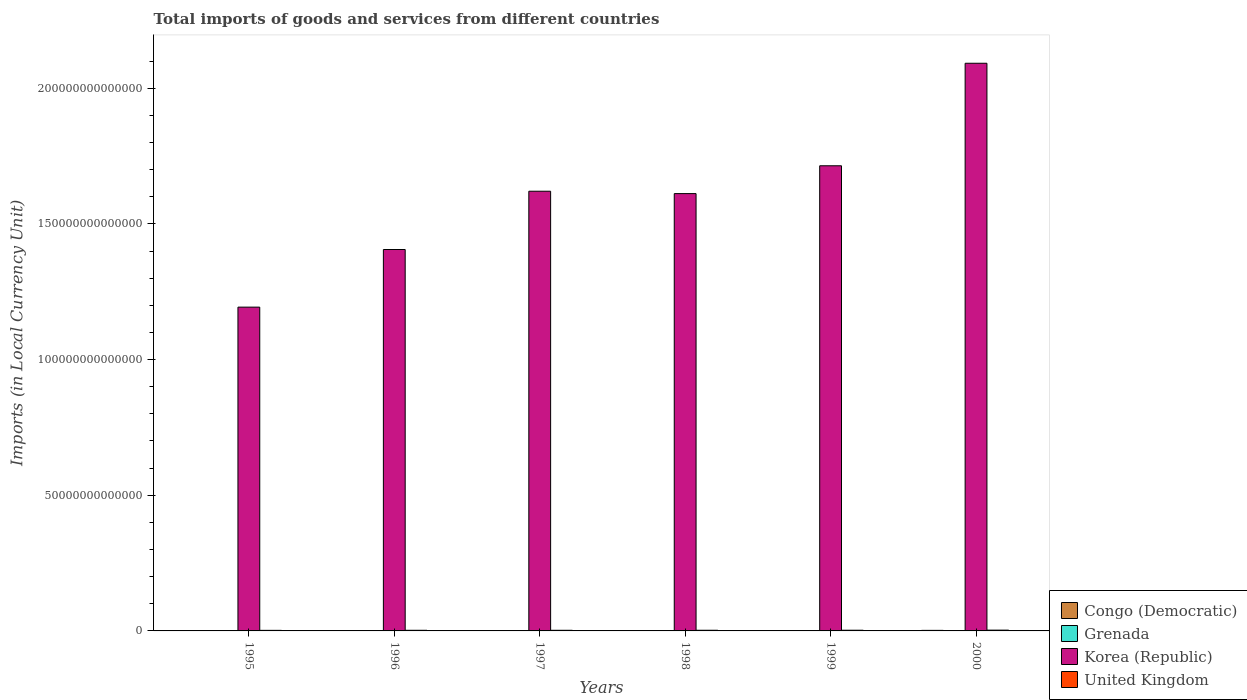How many different coloured bars are there?
Make the answer very short. 4. How many groups of bars are there?
Offer a very short reply. 6. Are the number of bars on each tick of the X-axis equal?
Ensure brevity in your answer.  Yes. How many bars are there on the 4th tick from the left?
Your response must be concise. 4. How many bars are there on the 3rd tick from the right?
Provide a short and direct response. 4. What is the label of the 3rd group of bars from the left?
Your answer should be compact. 1997. What is the Amount of goods and services imports in Grenada in 2000?
Provide a succinct answer. 8.37e+08. Across all years, what is the maximum Amount of goods and services imports in Grenada?
Your answer should be very brief. 8.37e+08. Across all years, what is the minimum Amount of goods and services imports in United Kingdom?
Your response must be concise. 2.10e+11. What is the total Amount of goods and services imports in United Kingdom in the graph?
Offer a very short reply. 1.47e+12. What is the difference between the Amount of goods and services imports in United Kingdom in 1997 and that in 1998?
Provide a short and direct response. -6.59e+09. What is the difference between the Amount of goods and services imports in United Kingdom in 1999 and the Amount of goods and services imports in Korea (Republic) in 1995?
Your response must be concise. -1.19e+14. What is the average Amount of goods and services imports in Congo (Democratic) per year?
Make the answer very short. 3.66e+1. In the year 1995, what is the difference between the Amount of goods and services imports in Congo (Democratic) and Amount of goods and services imports in Korea (Republic)?
Offer a very short reply. -1.19e+14. What is the ratio of the Amount of goods and services imports in Congo (Democratic) in 1995 to that in 1996?
Your answer should be compact. 0.11. Is the Amount of goods and services imports in United Kingdom in 1995 less than that in 1996?
Give a very brief answer. Yes. Is the difference between the Amount of goods and services imports in Congo (Democratic) in 1997 and 1998 greater than the difference between the Amount of goods and services imports in Korea (Republic) in 1997 and 1998?
Your response must be concise. No. What is the difference between the highest and the second highest Amount of goods and services imports in United Kingdom?
Give a very brief answer. 3.17e+1. What is the difference between the highest and the lowest Amount of goods and services imports in United Kingdom?
Ensure brevity in your answer.  7.99e+1. Is it the case that in every year, the sum of the Amount of goods and services imports in United Kingdom and Amount of goods and services imports in Grenada is greater than the sum of Amount of goods and services imports in Korea (Republic) and Amount of goods and services imports in Congo (Democratic)?
Provide a succinct answer. No. What does the 1st bar from the left in 1997 represents?
Provide a short and direct response. Congo (Democratic). What does the 2nd bar from the right in 1996 represents?
Offer a very short reply. Korea (Republic). Is it the case that in every year, the sum of the Amount of goods and services imports in Grenada and Amount of goods and services imports in Congo (Democratic) is greater than the Amount of goods and services imports in Korea (Republic)?
Provide a succinct answer. No. Are all the bars in the graph horizontal?
Offer a very short reply. No. What is the difference between two consecutive major ticks on the Y-axis?
Give a very brief answer. 5.00e+13. Does the graph contain any zero values?
Your response must be concise. No. How many legend labels are there?
Ensure brevity in your answer.  4. What is the title of the graph?
Keep it short and to the point. Total imports of goods and services from different countries. What is the label or title of the X-axis?
Offer a terse response. Years. What is the label or title of the Y-axis?
Give a very brief answer. Imports (in Local Currency Unit). What is the Imports (in Local Currency Unit) of Congo (Democratic) in 1995?
Ensure brevity in your answer.  9.41e+07. What is the Imports (in Local Currency Unit) of Grenada in 1995?
Your response must be concise. 4.12e+08. What is the Imports (in Local Currency Unit) in Korea (Republic) in 1995?
Ensure brevity in your answer.  1.19e+14. What is the Imports (in Local Currency Unit) in United Kingdom in 1995?
Offer a terse response. 2.10e+11. What is the Imports (in Local Currency Unit) of Congo (Democratic) in 1996?
Your answer should be very brief. 8.78e+08. What is the Imports (in Local Currency Unit) of Grenada in 1996?
Provide a short and direct response. 5.22e+08. What is the Imports (in Local Currency Unit) of Korea (Republic) in 1996?
Keep it short and to the point. 1.41e+14. What is the Imports (in Local Currency Unit) of United Kingdom in 1996?
Give a very brief answer. 2.30e+11. What is the Imports (in Local Currency Unit) of Congo (Democratic) in 1997?
Offer a very short reply. 1.20e+09. What is the Imports (in Local Currency Unit) of Grenada in 1997?
Provide a short and direct response. 5.74e+08. What is the Imports (in Local Currency Unit) in Korea (Republic) in 1997?
Ensure brevity in your answer.  1.62e+14. What is the Imports (in Local Currency Unit) of United Kingdom in 1997?
Make the answer very short. 2.35e+11. What is the Imports (in Local Currency Unit) of Congo (Democratic) in 1998?
Provide a short and direct response. 3.29e+09. What is the Imports (in Local Currency Unit) in Grenada in 1998?
Provide a short and direct response. 6.84e+08. What is the Imports (in Local Currency Unit) in Korea (Republic) in 1998?
Your answer should be compact. 1.61e+14. What is the Imports (in Local Currency Unit) in United Kingdom in 1998?
Ensure brevity in your answer.  2.42e+11. What is the Imports (in Local Currency Unit) of Congo (Democratic) in 1999?
Your response must be concise. 9.09e+09. What is the Imports (in Local Currency Unit) in Grenada in 1999?
Provide a succinct answer. 7.19e+08. What is the Imports (in Local Currency Unit) of Korea (Republic) in 1999?
Offer a very short reply. 1.71e+14. What is the Imports (in Local Currency Unit) of United Kingdom in 1999?
Your answer should be very brief. 2.58e+11. What is the Imports (in Local Currency Unit) in Congo (Democratic) in 2000?
Make the answer very short. 2.05e+11. What is the Imports (in Local Currency Unit) in Grenada in 2000?
Provide a succinct answer. 8.37e+08. What is the Imports (in Local Currency Unit) of Korea (Republic) in 2000?
Provide a short and direct response. 2.09e+14. What is the Imports (in Local Currency Unit) of United Kingdom in 2000?
Your response must be concise. 2.90e+11. Across all years, what is the maximum Imports (in Local Currency Unit) of Congo (Democratic)?
Offer a terse response. 2.05e+11. Across all years, what is the maximum Imports (in Local Currency Unit) in Grenada?
Offer a very short reply. 8.37e+08. Across all years, what is the maximum Imports (in Local Currency Unit) of Korea (Republic)?
Your answer should be very brief. 2.09e+14. Across all years, what is the maximum Imports (in Local Currency Unit) of United Kingdom?
Make the answer very short. 2.90e+11. Across all years, what is the minimum Imports (in Local Currency Unit) in Congo (Democratic)?
Provide a short and direct response. 9.41e+07. Across all years, what is the minimum Imports (in Local Currency Unit) of Grenada?
Provide a short and direct response. 4.12e+08. Across all years, what is the minimum Imports (in Local Currency Unit) of Korea (Republic)?
Offer a very short reply. 1.19e+14. Across all years, what is the minimum Imports (in Local Currency Unit) in United Kingdom?
Make the answer very short. 2.10e+11. What is the total Imports (in Local Currency Unit) in Congo (Democratic) in the graph?
Offer a very short reply. 2.20e+11. What is the total Imports (in Local Currency Unit) of Grenada in the graph?
Give a very brief answer. 3.75e+09. What is the total Imports (in Local Currency Unit) in Korea (Republic) in the graph?
Your answer should be compact. 9.64e+14. What is the total Imports (in Local Currency Unit) in United Kingdom in the graph?
Your answer should be very brief. 1.47e+12. What is the difference between the Imports (in Local Currency Unit) in Congo (Democratic) in 1995 and that in 1996?
Give a very brief answer. -7.84e+08. What is the difference between the Imports (in Local Currency Unit) in Grenada in 1995 and that in 1996?
Your answer should be compact. -1.09e+08. What is the difference between the Imports (in Local Currency Unit) in Korea (Republic) in 1995 and that in 1996?
Offer a terse response. -2.12e+13. What is the difference between the Imports (in Local Currency Unit) of United Kingdom in 1995 and that in 1996?
Offer a terse response. -2.02e+1. What is the difference between the Imports (in Local Currency Unit) in Congo (Democratic) in 1995 and that in 1997?
Your answer should be very brief. -1.11e+09. What is the difference between the Imports (in Local Currency Unit) of Grenada in 1995 and that in 1997?
Ensure brevity in your answer.  -1.62e+08. What is the difference between the Imports (in Local Currency Unit) in Korea (Republic) in 1995 and that in 1997?
Provide a short and direct response. -4.27e+13. What is the difference between the Imports (in Local Currency Unit) in United Kingdom in 1995 and that in 1997?
Make the answer very short. -2.52e+1. What is the difference between the Imports (in Local Currency Unit) in Congo (Democratic) in 1995 and that in 1998?
Offer a very short reply. -3.19e+09. What is the difference between the Imports (in Local Currency Unit) of Grenada in 1995 and that in 1998?
Provide a succinct answer. -2.71e+08. What is the difference between the Imports (in Local Currency Unit) in Korea (Republic) in 1995 and that in 1998?
Give a very brief answer. -4.18e+13. What is the difference between the Imports (in Local Currency Unit) of United Kingdom in 1995 and that in 1998?
Offer a very short reply. -3.18e+1. What is the difference between the Imports (in Local Currency Unit) in Congo (Democratic) in 1995 and that in 1999?
Make the answer very short. -9.00e+09. What is the difference between the Imports (in Local Currency Unit) of Grenada in 1995 and that in 1999?
Your response must be concise. -3.07e+08. What is the difference between the Imports (in Local Currency Unit) in Korea (Republic) in 1995 and that in 1999?
Provide a short and direct response. -5.21e+13. What is the difference between the Imports (in Local Currency Unit) in United Kingdom in 1995 and that in 1999?
Provide a succinct answer. -4.82e+1. What is the difference between the Imports (in Local Currency Unit) in Congo (Democratic) in 1995 and that in 2000?
Offer a terse response. -2.05e+11. What is the difference between the Imports (in Local Currency Unit) of Grenada in 1995 and that in 2000?
Ensure brevity in your answer.  -4.25e+08. What is the difference between the Imports (in Local Currency Unit) of Korea (Republic) in 1995 and that in 2000?
Keep it short and to the point. -8.99e+13. What is the difference between the Imports (in Local Currency Unit) of United Kingdom in 1995 and that in 2000?
Make the answer very short. -7.99e+1. What is the difference between the Imports (in Local Currency Unit) of Congo (Democratic) in 1996 and that in 1997?
Make the answer very short. -3.22e+08. What is the difference between the Imports (in Local Currency Unit) of Grenada in 1996 and that in 1997?
Provide a short and direct response. -5.24e+07. What is the difference between the Imports (in Local Currency Unit) of Korea (Republic) in 1996 and that in 1997?
Provide a succinct answer. -2.15e+13. What is the difference between the Imports (in Local Currency Unit) of United Kingdom in 1996 and that in 1997?
Provide a succinct answer. -4.98e+09. What is the difference between the Imports (in Local Currency Unit) of Congo (Democratic) in 1996 and that in 1998?
Your response must be concise. -2.41e+09. What is the difference between the Imports (in Local Currency Unit) of Grenada in 1996 and that in 1998?
Offer a very short reply. -1.62e+08. What is the difference between the Imports (in Local Currency Unit) in Korea (Republic) in 1996 and that in 1998?
Provide a succinct answer. -2.06e+13. What is the difference between the Imports (in Local Currency Unit) of United Kingdom in 1996 and that in 1998?
Your response must be concise. -1.16e+1. What is the difference between the Imports (in Local Currency Unit) of Congo (Democratic) in 1996 and that in 1999?
Your answer should be very brief. -8.21e+09. What is the difference between the Imports (in Local Currency Unit) in Grenada in 1996 and that in 1999?
Offer a terse response. -1.97e+08. What is the difference between the Imports (in Local Currency Unit) in Korea (Republic) in 1996 and that in 1999?
Your answer should be compact. -3.09e+13. What is the difference between the Imports (in Local Currency Unit) in United Kingdom in 1996 and that in 1999?
Offer a very short reply. -2.80e+1. What is the difference between the Imports (in Local Currency Unit) of Congo (Democratic) in 1996 and that in 2000?
Ensure brevity in your answer.  -2.04e+11. What is the difference between the Imports (in Local Currency Unit) of Grenada in 1996 and that in 2000?
Offer a terse response. -3.16e+08. What is the difference between the Imports (in Local Currency Unit) in Korea (Republic) in 1996 and that in 2000?
Offer a very short reply. -6.86e+13. What is the difference between the Imports (in Local Currency Unit) of United Kingdom in 1996 and that in 2000?
Provide a short and direct response. -5.97e+1. What is the difference between the Imports (in Local Currency Unit) of Congo (Democratic) in 1997 and that in 1998?
Provide a succinct answer. -2.09e+09. What is the difference between the Imports (in Local Currency Unit) of Grenada in 1997 and that in 1998?
Give a very brief answer. -1.10e+08. What is the difference between the Imports (in Local Currency Unit) of Korea (Republic) in 1997 and that in 1998?
Your answer should be very brief. 8.76e+11. What is the difference between the Imports (in Local Currency Unit) in United Kingdom in 1997 and that in 1998?
Provide a short and direct response. -6.59e+09. What is the difference between the Imports (in Local Currency Unit) of Congo (Democratic) in 1997 and that in 1999?
Your answer should be compact. -7.89e+09. What is the difference between the Imports (in Local Currency Unit) in Grenada in 1997 and that in 1999?
Keep it short and to the point. -1.45e+08. What is the difference between the Imports (in Local Currency Unit) of Korea (Republic) in 1997 and that in 1999?
Your answer should be compact. -9.38e+12. What is the difference between the Imports (in Local Currency Unit) in United Kingdom in 1997 and that in 1999?
Your response must be concise. -2.30e+1. What is the difference between the Imports (in Local Currency Unit) of Congo (Democratic) in 1997 and that in 2000?
Make the answer very short. -2.04e+11. What is the difference between the Imports (in Local Currency Unit) of Grenada in 1997 and that in 2000?
Your answer should be very brief. -2.63e+08. What is the difference between the Imports (in Local Currency Unit) in Korea (Republic) in 1997 and that in 2000?
Your answer should be very brief. -4.72e+13. What is the difference between the Imports (in Local Currency Unit) in United Kingdom in 1997 and that in 2000?
Provide a succinct answer. -5.47e+1. What is the difference between the Imports (in Local Currency Unit) in Congo (Democratic) in 1998 and that in 1999?
Your answer should be very brief. -5.81e+09. What is the difference between the Imports (in Local Currency Unit) in Grenada in 1998 and that in 1999?
Offer a terse response. -3.54e+07. What is the difference between the Imports (in Local Currency Unit) of Korea (Republic) in 1998 and that in 1999?
Give a very brief answer. -1.03e+13. What is the difference between the Imports (in Local Currency Unit) in United Kingdom in 1998 and that in 1999?
Keep it short and to the point. -1.64e+1. What is the difference between the Imports (in Local Currency Unit) of Congo (Democratic) in 1998 and that in 2000?
Provide a succinct answer. -2.02e+11. What is the difference between the Imports (in Local Currency Unit) in Grenada in 1998 and that in 2000?
Provide a succinct answer. -1.54e+08. What is the difference between the Imports (in Local Currency Unit) of Korea (Republic) in 1998 and that in 2000?
Make the answer very short. -4.80e+13. What is the difference between the Imports (in Local Currency Unit) of United Kingdom in 1998 and that in 2000?
Your answer should be compact. -4.81e+1. What is the difference between the Imports (in Local Currency Unit) of Congo (Democratic) in 1999 and that in 2000?
Provide a succinct answer. -1.96e+11. What is the difference between the Imports (in Local Currency Unit) of Grenada in 1999 and that in 2000?
Give a very brief answer. -1.18e+08. What is the difference between the Imports (in Local Currency Unit) in Korea (Republic) in 1999 and that in 2000?
Give a very brief answer. -3.78e+13. What is the difference between the Imports (in Local Currency Unit) of United Kingdom in 1999 and that in 2000?
Offer a very short reply. -3.17e+1. What is the difference between the Imports (in Local Currency Unit) of Congo (Democratic) in 1995 and the Imports (in Local Currency Unit) of Grenada in 1996?
Give a very brief answer. -4.28e+08. What is the difference between the Imports (in Local Currency Unit) of Congo (Democratic) in 1995 and the Imports (in Local Currency Unit) of Korea (Republic) in 1996?
Provide a succinct answer. -1.41e+14. What is the difference between the Imports (in Local Currency Unit) of Congo (Democratic) in 1995 and the Imports (in Local Currency Unit) of United Kingdom in 1996?
Provide a short and direct response. -2.30e+11. What is the difference between the Imports (in Local Currency Unit) in Grenada in 1995 and the Imports (in Local Currency Unit) in Korea (Republic) in 1996?
Your response must be concise. -1.41e+14. What is the difference between the Imports (in Local Currency Unit) of Grenada in 1995 and the Imports (in Local Currency Unit) of United Kingdom in 1996?
Make the answer very short. -2.30e+11. What is the difference between the Imports (in Local Currency Unit) of Korea (Republic) in 1995 and the Imports (in Local Currency Unit) of United Kingdom in 1996?
Your answer should be compact. 1.19e+14. What is the difference between the Imports (in Local Currency Unit) in Congo (Democratic) in 1995 and the Imports (in Local Currency Unit) in Grenada in 1997?
Your answer should be compact. -4.80e+08. What is the difference between the Imports (in Local Currency Unit) of Congo (Democratic) in 1995 and the Imports (in Local Currency Unit) of Korea (Republic) in 1997?
Offer a very short reply. -1.62e+14. What is the difference between the Imports (in Local Currency Unit) of Congo (Democratic) in 1995 and the Imports (in Local Currency Unit) of United Kingdom in 1997?
Provide a short and direct response. -2.35e+11. What is the difference between the Imports (in Local Currency Unit) in Grenada in 1995 and the Imports (in Local Currency Unit) in Korea (Republic) in 1997?
Give a very brief answer. -1.62e+14. What is the difference between the Imports (in Local Currency Unit) of Grenada in 1995 and the Imports (in Local Currency Unit) of United Kingdom in 1997?
Your answer should be very brief. -2.35e+11. What is the difference between the Imports (in Local Currency Unit) in Korea (Republic) in 1995 and the Imports (in Local Currency Unit) in United Kingdom in 1997?
Your response must be concise. 1.19e+14. What is the difference between the Imports (in Local Currency Unit) in Congo (Democratic) in 1995 and the Imports (in Local Currency Unit) in Grenada in 1998?
Give a very brief answer. -5.90e+08. What is the difference between the Imports (in Local Currency Unit) of Congo (Democratic) in 1995 and the Imports (in Local Currency Unit) of Korea (Republic) in 1998?
Offer a very short reply. -1.61e+14. What is the difference between the Imports (in Local Currency Unit) in Congo (Democratic) in 1995 and the Imports (in Local Currency Unit) in United Kingdom in 1998?
Make the answer very short. -2.42e+11. What is the difference between the Imports (in Local Currency Unit) of Grenada in 1995 and the Imports (in Local Currency Unit) of Korea (Republic) in 1998?
Ensure brevity in your answer.  -1.61e+14. What is the difference between the Imports (in Local Currency Unit) in Grenada in 1995 and the Imports (in Local Currency Unit) in United Kingdom in 1998?
Ensure brevity in your answer.  -2.41e+11. What is the difference between the Imports (in Local Currency Unit) in Korea (Republic) in 1995 and the Imports (in Local Currency Unit) in United Kingdom in 1998?
Make the answer very short. 1.19e+14. What is the difference between the Imports (in Local Currency Unit) in Congo (Democratic) in 1995 and the Imports (in Local Currency Unit) in Grenada in 1999?
Your answer should be compact. -6.25e+08. What is the difference between the Imports (in Local Currency Unit) of Congo (Democratic) in 1995 and the Imports (in Local Currency Unit) of Korea (Republic) in 1999?
Provide a succinct answer. -1.71e+14. What is the difference between the Imports (in Local Currency Unit) in Congo (Democratic) in 1995 and the Imports (in Local Currency Unit) in United Kingdom in 1999?
Keep it short and to the point. -2.58e+11. What is the difference between the Imports (in Local Currency Unit) in Grenada in 1995 and the Imports (in Local Currency Unit) in Korea (Republic) in 1999?
Offer a terse response. -1.71e+14. What is the difference between the Imports (in Local Currency Unit) in Grenada in 1995 and the Imports (in Local Currency Unit) in United Kingdom in 1999?
Provide a short and direct response. -2.58e+11. What is the difference between the Imports (in Local Currency Unit) in Korea (Republic) in 1995 and the Imports (in Local Currency Unit) in United Kingdom in 1999?
Ensure brevity in your answer.  1.19e+14. What is the difference between the Imports (in Local Currency Unit) of Congo (Democratic) in 1995 and the Imports (in Local Currency Unit) of Grenada in 2000?
Keep it short and to the point. -7.43e+08. What is the difference between the Imports (in Local Currency Unit) of Congo (Democratic) in 1995 and the Imports (in Local Currency Unit) of Korea (Republic) in 2000?
Your response must be concise. -2.09e+14. What is the difference between the Imports (in Local Currency Unit) of Congo (Democratic) in 1995 and the Imports (in Local Currency Unit) of United Kingdom in 2000?
Give a very brief answer. -2.90e+11. What is the difference between the Imports (in Local Currency Unit) of Grenada in 1995 and the Imports (in Local Currency Unit) of Korea (Republic) in 2000?
Offer a very short reply. -2.09e+14. What is the difference between the Imports (in Local Currency Unit) in Grenada in 1995 and the Imports (in Local Currency Unit) in United Kingdom in 2000?
Your response must be concise. -2.90e+11. What is the difference between the Imports (in Local Currency Unit) in Korea (Republic) in 1995 and the Imports (in Local Currency Unit) in United Kingdom in 2000?
Ensure brevity in your answer.  1.19e+14. What is the difference between the Imports (in Local Currency Unit) in Congo (Democratic) in 1996 and the Imports (in Local Currency Unit) in Grenada in 1997?
Offer a very short reply. 3.04e+08. What is the difference between the Imports (in Local Currency Unit) of Congo (Democratic) in 1996 and the Imports (in Local Currency Unit) of Korea (Republic) in 1997?
Ensure brevity in your answer.  -1.62e+14. What is the difference between the Imports (in Local Currency Unit) of Congo (Democratic) in 1996 and the Imports (in Local Currency Unit) of United Kingdom in 1997?
Give a very brief answer. -2.34e+11. What is the difference between the Imports (in Local Currency Unit) in Grenada in 1996 and the Imports (in Local Currency Unit) in Korea (Republic) in 1997?
Provide a succinct answer. -1.62e+14. What is the difference between the Imports (in Local Currency Unit) of Grenada in 1996 and the Imports (in Local Currency Unit) of United Kingdom in 1997?
Provide a short and direct response. -2.35e+11. What is the difference between the Imports (in Local Currency Unit) of Korea (Republic) in 1996 and the Imports (in Local Currency Unit) of United Kingdom in 1997?
Offer a very short reply. 1.40e+14. What is the difference between the Imports (in Local Currency Unit) in Congo (Democratic) in 1996 and the Imports (in Local Currency Unit) in Grenada in 1998?
Keep it short and to the point. 1.94e+08. What is the difference between the Imports (in Local Currency Unit) in Congo (Democratic) in 1996 and the Imports (in Local Currency Unit) in Korea (Republic) in 1998?
Your response must be concise. -1.61e+14. What is the difference between the Imports (in Local Currency Unit) of Congo (Democratic) in 1996 and the Imports (in Local Currency Unit) of United Kingdom in 1998?
Your answer should be compact. -2.41e+11. What is the difference between the Imports (in Local Currency Unit) of Grenada in 1996 and the Imports (in Local Currency Unit) of Korea (Republic) in 1998?
Offer a terse response. -1.61e+14. What is the difference between the Imports (in Local Currency Unit) of Grenada in 1996 and the Imports (in Local Currency Unit) of United Kingdom in 1998?
Your answer should be very brief. -2.41e+11. What is the difference between the Imports (in Local Currency Unit) in Korea (Republic) in 1996 and the Imports (in Local Currency Unit) in United Kingdom in 1998?
Provide a short and direct response. 1.40e+14. What is the difference between the Imports (in Local Currency Unit) in Congo (Democratic) in 1996 and the Imports (in Local Currency Unit) in Grenada in 1999?
Give a very brief answer. 1.59e+08. What is the difference between the Imports (in Local Currency Unit) in Congo (Democratic) in 1996 and the Imports (in Local Currency Unit) in Korea (Republic) in 1999?
Your answer should be compact. -1.71e+14. What is the difference between the Imports (in Local Currency Unit) of Congo (Democratic) in 1996 and the Imports (in Local Currency Unit) of United Kingdom in 1999?
Your answer should be very brief. -2.57e+11. What is the difference between the Imports (in Local Currency Unit) in Grenada in 1996 and the Imports (in Local Currency Unit) in Korea (Republic) in 1999?
Your answer should be very brief. -1.71e+14. What is the difference between the Imports (in Local Currency Unit) of Grenada in 1996 and the Imports (in Local Currency Unit) of United Kingdom in 1999?
Offer a very short reply. -2.58e+11. What is the difference between the Imports (in Local Currency Unit) of Korea (Republic) in 1996 and the Imports (in Local Currency Unit) of United Kingdom in 1999?
Provide a short and direct response. 1.40e+14. What is the difference between the Imports (in Local Currency Unit) in Congo (Democratic) in 1996 and the Imports (in Local Currency Unit) in Grenada in 2000?
Give a very brief answer. 4.06e+07. What is the difference between the Imports (in Local Currency Unit) of Congo (Democratic) in 1996 and the Imports (in Local Currency Unit) of Korea (Republic) in 2000?
Give a very brief answer. -2.09e+14. What is the difference between the Imports (in Local Currency Unit) of Congo (Democratic) in 1996 and the Imports (in Local Currency Unit) of United Kingdom in 2000?
Offer a terse response. -2.89e+11. What is the difference between the Imports (in Local Currency Unit) in Grenada in 1996 and the Imports (in Local Currency Unit) in Korea (Republic) in 2000?
Offer a very short reply. -2.09e+14. What is the difference between the Imports (in Local Currency Unit) of Grenada in 1996 and the Imports (in Local Currency Unit) of United Kingdom in 2000?
Give a very brief answer. -2.89e+11. What is the difference between the Imports (in Local Currency Unit) of Korea (Republic) in 1996 and the Imports (in Local Currency Unit) of United Kingdom in 2000?
Provide a short and direct response. 1.40e+14. What is the difference between the Imports (in Local Currency Unit) of Congo (Democratic) in 1997 and the Imports (in Local Currency Unit) of Grenada in 1998?
Keep it short and to the point. 5.16e+08. What is the difference between the Imports (in Local Currency Unit) of Congo (Democratic) in 1997 and the Imports (in Local Currency Unit) of Korea (Republic) in 1998?
Provide a short and direct response. -1.61e+14. What is the difference between the Imports (in Local Currency Unit) in Congo (Democratic) in 1997 and the Imports (in Local Currency Unit) in United Kingdom in 1998?
Offer a terse response. -2.41e+11. What is the difference between the Imports (in Local Currency Unit) of Grenada in 1997 and the Imports (in Local Currency Unit) of Korea (Republic) in 1998?
Offer a terse response. -1.61e+14. What is the difference between the Imports (in Local Currency Unit) in Grenada in 1997 and the Imports (in Local Currency Unit) in United Kingdom in 1998?
Provide a succinct answer. -2.41e+11. What is the difference between the Imports (in Local Currency Unit) in Korea (Republic) in 1997 and the Imports (in Local Currency Unit) in United Kingdom in 1998?
Ensure brevity in your answer.  1.62e+14. What is the difference between the Imports (in Local Currency Unit) in Congo (Democratic) in 1997 and the Imports (in Local Currency Unit) in Grenada in 1999?
Offer a terse response. 4.81e+08. What is the difference between the Imports (in Local Currency Unit) in Congo (Democratic) in 1997 and the Imports (in Local Currency Unit) in Korea (Republic) in 1999?
Offer a very short reply. -1.71e+14. What is the difference between the Imports (in Local Currency Unit) of Congo (Democratic) in 1997 and the Imports (in Local Currency Unit) of United Kingdom in 1999?
Your answer should be very brief. -2.57e+11. What is the difference between the Imports (in Local Currency Unit) in Grenada in 1997 and the Imports (in Local Currency Unit) in Korea (Republic) in 1999?
Provide a succinct answer. -1.71e+14. What is the difference between the Imports (in Local Currency Unit) of Grenada in 1997 and the Imports (in Local Currency Unit) of United Kingdom in 1999?
Your response must be concise. -2.58e+11. What is the difference between the Imports (in Local Currency Unit) of Korea (Republic) in 1997 and the Imports (in Local Currency Unit) of United Kingdom in 1999?
Your response must be concise. 1.62e+14. What is the difference between the Imports (in Local Currency Unit) in Congo (Democratic) in 1997 and the Imports (in Local Currency Unit) in Grenada in 2000?
Your answer should be very brief. 3.63e+08. What is the difference between the Imports (in Local Currency Unit) of Congo (Democratic) in 1997 and the Imports (in Local Currency Unit) of Korea (Republic) in 2000?
Provide a succinct answer. -2.09e+14. What is the difference between the Imports (in Local Currency Unit) in Congo (Democratic) in 1997 and the Imports (in Local Currency Unit) in United Kingdom in 2000?
Your response must be concise. -2.89e+11. What is the difference between the Imports (in Local Currency Unit) of Grenada in 1997 and the Imports (in Local Currency Unit) of Korea (Republic) in 2000?
Make the answer very short. -2.09e+14. What is the difference between the Imports (in Local Currency Unit) in Grenada in 1997 and the Imports (in Local Currency Unit) in United Kingdom in 2000?
Keep it short and to the point. -2.89e+11. What is the difference between the Imports (in Local Currency Unit) of Korea (Republic) in 1997 and the Imports (in Local Currency Unit) of United Kingdom in 2000?
Your answer should be compact. 1.62e+14. What is the difference between the Imports (in Local Currency Unit) in Congo (Democratic) in 1998 and the Imports (in Local Currency Unit) in Grenada in 1999?
Your response must be concise. 2.57e+09. What is the difference between the Imports (in Local Currency Unit) of Congo (Democratic) in 1998 and the Imports (in Local Currency Unit) of Korea (Republic) in 1999?
Give a very brief answer. -1.71e+14. What is the difference between the Imports (in Local Currency Unit) of Congo (Democratic) in 1998 and the Imports (in Local Currency Unit) of United Kingdom in 1999?
Your answer should be compact. -2.55e+11. What is the difference between the Imports (in Local Currency Unit) in Grenada in 1998 and the Imports (in Local Currency Unit) in Korea (Republic) in 1999?
Your answer should be compact. -1.71e+14. What is the difference between the Imports (in Local Currency Unit) of Grenada in 1998 and the Imports (in Local Currency Unit) of United Kingdom in 1999?
Offer a terse response. -2.58e+11. What is the difference between the Imports (in Local Currency Unit) of Korea (Republic) in 1998 and the Imports (in Local Currency Unit) of United Kingdom in 1999?
Give a very brief answer. 1.61e+14. What is the difference between the Imports (in Local Currency Unit) of Congo (Democratic) in 1998 and the Imports (in Local Currency Unit) of Grenada in 2000?
Your answer should be compact. 2.45e+09. What is the difference between the Imports (in Local Currency Unit) of Congo (Democratic) in 1998 and the Imports (in Local Currency Unit) of Korea (Republic) in 2000?
Your answer should be compact. -2.09e+14. What is the difference between the Imports (in Local Currency Unit) in Congo (Democratic) in 1998 and the Imports (in Local Currency Unit) in United Kingdom in 2000?
Your response must be concise. -2.87e+11. What is the difference between the Imports (in Local Currency Unit) of Grenada in 1998 and the Imports (in Local Currency Unit) of Korea (Republic) in 2000?
Your answer should be compact. -2.09e+14. What is the difference between the Imports (in Local Currency Unit) of Grenada in 1998 and the Imports (in Local Currency Unit) of United Kingdom in 2000?
Give a very brief answer. -2.89e+11. What is the difference between the Imports (in Local Currency Unit) of Korea (Republic) in 1998 and the Imports (in Local Currency Unit) of United Kingdom in 2000?
Keep it short and to the point. 1.61e+14. What is the difference between the Imports (in Local Currency Unit) in Congo (Democratic) in 1999 and the Imports (in Local Currency Unit) in Grenada in 2000?
Provide a short and direct response. 8.25e+09. What is the difference between the Imports (in Local Currency Unit) of Congo (Democratic) in 1999 and the Imports (in Local Currency Unit) of Korea (Republic) in 2000?
Provide a succinct answer. -2.09e+14. What is the difference between the Imports (in Local Currency Unit) in Congo (Democratic) in 1999 and the Imports (in Local Currency Unit) in United Kingdom in 2000?
Provide a short and direct response. -2.81e+11. What is the difference between the Imports (in Local Currency Unit) of Grenada in 1999 and the Imports (in Local Currency Unit) of Korea (Republic) in 2000?
Provide a short and direct response. -2.09e+14. What is the difference between the Imports (in Local Currency Unit) in Grenada in 1999 and the Imports (in Local Currency Unit) in United Kingdom in 2000?
Provide a short and direct response. -2.89e+11. What is the difference between the Imports (in Local Currency Unit) in Korea (Republic) in 1999 and the Imports (in Local Currency Unit) in United Kingdom in 2000?
Your answer should be very brief. 1.71e+14. What is the average Imports (in Local Currency Unit) in Congo (Democratic) per year?
Offer a terse response. 3.66e+1. What is the average Imports (in Local Currency Unit) of Grenada per year?
Provide a short and direct response. 6.25e+08. What is the average Imports (in Local Currency Unit) in Korea (Republic) per year?
Ensure brevity in your answer.  1.61e+14. What is the average Imports (in Local Currency Unit) in United Kingdom per year?
Your answer should be very brief. 2.44e+11. In the year 1995, what is the difference between the Imports (in Local Currency Unit) of Congo (Democratic) and Imports (in Local Currency Unit) of Grenada?
Ensure brevity in your answer.  -3.18e+08. In the year 1995, what is the difference between the Imports (in Local Currency Unit) in Congo (Democratic) and Imports (in Local Currency Unit) in Korea (Republic)?
Offer a very short reply. -1.19e+14. In the year 1995, what is the difference between the Imports (in Local Currency Unit) of Congo (Democratic) and Imports (in Local Currency Unit) of United Kingdom?
Offer a very short reply. -2.10e+11. In the year 1995, what is the difference between the Imports (in Local Currency Unit) in Grenada and Imports (in Local Currency Unit) in Korea (Republic)?
Make the answer very short. -1.19e+14. In the year 1995, what is the difference between the Imports (in Local Currency Unit) in Grenada and Imports (in Local Currency Unit) in United Kingdom?
Your response must be concise. -2.10e+11. In the year 1995, what is the difference between the Imports (in Local Currency Unit) in Korea (Republic) and Imports (in Local Currency Unit) in United Kingdom?
Your response must be concise. 1.19e+14. In the year 1996, what is the difference between the Imports (in Local Currency Unit) in Congo (Democratic) and Imports (in Local Currency Unit) in Grenada?
Give a very brief answer. 3.56e+08. In the year 1996, what is the difference between the Imports (in Local Currency Unit) in Congo (Democratic) and Imports (in Local Currency Unit) in Korea (Republic)?
Ensure brevity in your answer.  -1.41e+14. In the year 1996, what is the difference between the Imports (in Local Currency Unit) of Congo (Democratic) and Imports (in Local Currency Unit) of United Kingdom?
Ensure brevity in your answer.  -2.29e+11. In the year 1996, what is the difference between the Imports (in Local Currency Unit) of Grenada and Imports (in Local Currency Unit) of Korea (Republic)?
Your answer should be compact. -1.41e+14. In the year 1996, what is the difference between the Imports (in Local Currency Unit) of Grenada and Imports (in Local Currency Unit) of United Kingdom?
Offer a terse response. -2.30e+11. In the year 1996, what is the difference between the Imports (in Local Currency Unit) of Korea (Republic) and Imports (in Local Currency Unit) of United Kingdom?
Provide a succinct answer. 1.40e+14. In the year 1997, what is the difference between the Imports (in Local Currency Unit) of Congo (Democratic) and Imports (in Local Currency Unit) of Grenada?
Your response must be concise. 6.26e+08. In the year 1997, what is the difference between the Imports (in Local Currency Unit) of Congo (Democratic) and Imports (in Local Currency Unit) of Korea (Republic)?
Provide a succinct answer. -1.62e+14. In the year 1997, what is the difference between the Imports (in Local Currency Unit) in Congo (Democratic) and Imports (in Local Currency Unit) in United Kingdom?
Your answer should be very brief. -2.34e+11. In the year 1997, what is the difference between the Imports (in Local Currency Unit) in Grenada and Imports (in Local Currency Unit) in Korea (Republic)?
Your answer should be compact. -1.62e+14. In the year 1997, what is the difference between the Imports (in Local Currency Unit) of Grenada and Imports (in Local Currency Unit) of United Kingdom?
Your answer should be compact. -2.35e+11. In the year 1997, what is the difference between the Imports (in Local Currency Unit) of Korea (Republic) and Imports (in Local Currency Unit) of United Kingdom?
Provide a succinct answer. 1.62e+14. In the year 1998, what is the difference between the Imports (in Local Currency Unit) in Congo (Democratic) and Imports (in Local Currency Unit) in Grenada?
Provide a succinct answer. 2.60e+09. In the year 1998, what is the difference between the Imports (in Local Currency Unit) of Congo (Democratic) and Imports (in Local Currency Unit) of Korea (Republic)?
Ensure brevity in your answer.  -1.61e+14. In the year 1998, what is the difference between the Imports (in Local Currency Unit) in Congo (Democratic) and Imports (in Local Currency Unit) in United Kingdom?
Keep it short and to the point. -2.39e+11. In the year 1998, what is the difference between the Imports (in Local Currency Unit) in Grenada and Imports (in Local Currency Unit) in Korea (Republic)?
Your answer should be compact. -1.61e+14. In the year 1998, what is the difference between the Imports (in Local Currency Unit) of Grenada and Imports (in Local Currency Unit) of United Kingdom?
Make the answer very short. -2.41e+11. In the year 1998, what is the difference between the Imports (in Local Currency Unit) of Korea (Republic) and Imports (in Local Currency Unit) of United Kingdom?
Give a very brief answer. 1.61e+14. In the year 1999, what is the difference between the Imports (in Local Currency Unit) of Congo (Democratic) and Imports (in Local Currency Unit) of Grenada?
Make the answer very short. 8.37e+09. In the year 1999, what is the difference between the Imports (in Local Currency Unit) of Congo (Democratic) and Imports (in Local Currency Unit) of Korea (Republic)?
Offer a terse response. -1.71e+14. In the year 1999, what is the difference between the Imports (in Local Currency Unit) in Congo (Democratic) and Imports (in Local Currency Unit) in United Kingdom?
Your response must be concise. -2.49e+11. In the year 1999, what is the difference between the Imports (in Local Currency Unit) in Grenada and Imports (in Local Currency Unit) in Korea (Republic)?
Keep it short and to the point. -1.71e+14. In the year 1999, what is the difference between the Imports (in Local Currency Unit) of Grenada and Imports (in Local Currency Unit) of United Kingdom?
Your answer should be very brief. -2.58e+11. In the year 1999, what is the difference between the Imports (in Local Currency Unit) in Korea (Republic) and Imports (in Local Currency Unit) in United Kingdom?
Your answer should be compact. 1.71e+14. In the year 2000, what is the difference between the Imports (in Local Currency Unit) of Congo (Democratic) and Imports (in Local Currency Unit) of Grenada?
Your answer should be very brief. 2.04e+11. In the year 2000, what is the difference between the Imports (in Local Currency Unit) in Congo (Democratic) and Imports (in Local Currency Unit) in Korea (Republic)?
Make the answer very short. -2.09e+14. In the year 2000, what is the difference between the Imports (in Local Currency Unit) of Congo (Democratic) and Imports (in Local Currency Unit) of United Kingdom?
Ensure brevity in your answer.  -8.50e+1. In the year 2000, what is the difference between the Imports (in Local Currency Unit) of Grenada and Imports (in Local Currency Unit) of Korea (Republic)?
Provide a short and direct response. -2.09e+14. In the year 2000, what is the difference between the Imports (in Local Currency Unit) in Grenada and Imports (in Local Currency Unit) in United Kingdom?
Ensure brevity in your answer.  -2.89e+11. In the year 2000, what is the difference between the Imports (in Local Currency Unit) of Korea (Republic) and Imports (in Local Currency Unit) of United Kingdom?
Make the answer very short. 2.09e+14. What is the ratio of the Imports (in Local Currency Unit) of Congo (Democratic) in 1995 to that in 1996?
Provide a succinct answer. 0.11. What is the ratio of the Imports (in Local Currency Unit) of Grenada in 1995 to that in 1996?
Ensure brevity in your answer.  0.79. What is the ratio of the Imports (in Local Currency Unit) of Korea (Republic) in 1995 to that in 1996?
Offer a very short reply. 0.85. What is the ratio of the Imports (in Local Currency Unit) of United Kingdom in 1995 to that in 1996?
Make the answer very short. 0.91. What is the ratio of the Imports (in Local Currency Unit) in Congo (Democratic) in 1995 to that in 1997?
Your response must be concise. 0.08. What is the ratio of the Imports (in Local Currency Unit) of Grenada in 1995 to that in 1997?
Your response must be concise. 0.72. What is the ratio of the Imports (in Local Currency Unit) in Korea (Republic) in 1995 to that in 1997?
Your answer should be very brief. 0.74. What is the ratio of the Imports (in Local Currency Unit) of United Kingdom in 1995 to that in 1997?
Make the answer very short. 0.89. What is the ratio of the Imports (in Local Currency Unit) of Congo (Democratic) in 1995 to that in 1998?
Your answer should be very brief. 0.03. What is the ratio of the Imports (in Local Currency Unit) in Grenada in 1995 to that in 1998?
Provide a succinct answer. 0.6. What is the ratio of the Imports (in Local Currency Unit) in Korea (Republic) in 1995 to that in 1998?
Keep it short and to the point. 0.74. What is the ratio of the Imports (in Local Currency Unit) in United Kingdom in 1995 to that in 1998?
Provide a succinct answer. 0.87. What is the ratio of the Imports (in Local Currency Unit) of Congo (Democratic) in 1995 to that in 1999?
Keep it short and to the point. 0.01. What is the ratio of the Imports (in Local Currency Unit) in Grenada in 1995 to that in 1999?
Your response must be concise. 0.57. What is the ratio of the Imports (in Local Currency Unit) of Korea (Republic) in 1995 to that in 1999?
Your answer should be compact. 0.7. What is the ratio of the Imports (in Local Currency Unit) in United Kingdom in 1995 to that in 1999?
Ensure brevity in your answer.  0.81. What is the ratio of the Imports (in Local Currency Unit) of Congo (Democratic) in 1995 to that in 2000?
Your response must be concise. 0. What is the ratio of the Imports (in Local Currency Unit) in Grenada in 1995 to that in 2000?
Your answer should be compact. 0.49. What is the ratio of the Imports (in Local Currency Unit) in Korea (Republic) in 1995 to that in 2000?
Offer a terse response. 0.57. What is the ratio of the Imports (in Local Currency Unit) in United Kingdom in 1995 to that in 2000?
Provide a succinct answer. 0.72. What is the ratio of the Imports (in Local Currency Unit) of Congo (Democratic) in 1996 to that in 1997?
Your answer should be very brief. 0.73. What is the ratio of the Imports (in Local Currency Unit) of Grenada in 1996 to that in 1997?
Your answer should be very brief. 0.91. What is the ratio of the Imports (in Local Currency Unit) of Korea (Republic) in 1996 to that in 1997?
Offer a very short reply. 0.87. What is the ratio of the Imports (in Local Currency Unit) of United Kingdom in 1996 to that in 1997?
Make the answer very short. 0.98. What is the ratio of the Imports (in Local Currency Unit) in Congo (Democratic) in 1996 to that in 1998?
Provide a succinct answer. 0.27. What is the ratio of the Imports (in Local Currency Unit) of Grenada in 1996 to that in 1998?
Your answer should be compact. 0.76. What is the ratio of the Imports (in Local Currency Unit) in Korea (Republic) in 1996 to that in 1998?
Provide a succinct answer. 0.87. What is the ratio of the Imports (in Local Currency Unit) in United Kingdom in 1996 to that in 1998?
Ensure brevity in your answer.  0.95. What is the ratio of the Imports (in Local Currency Unit) in Congo (Democratic) in 1996 to that in 1999?
Offer a terse response. 0.1. What is the ratio of the Imports (in Local Currency Unit) of Grenada in 1996 to that in 1999?
Provide a succinct answer. 0.73. What is the ratio of the Imports (in Local Currency Unit) of Korea (Republic) in 1996 to that in 1999?
Your response must be concise. 0.82. What is the ratio of the Imports (in Local Currency Unit) in United Kingdom in 1996 to that in 1999?
Your response must be concise. 0.89. What is the ratio of the Imports (in Local Currency Unit) in Congo (Democratic) in 1996 to that in 2000?
Keep it short and to the point. 0. What is the ratio of the Imports (in Local Currency Unit) in Grenada in 1996 to that in 2000?
Make the answer very short. 0.62. What is the ratio of the Imports (in Local Currency Unit) in Korea (Republic) in 1996 to that in 2000?
Your answer should be very brief. 0.67. What is the ratio of the Imports (in Local Currency Unit) of United Kingdom in 1996 to that in 2000?
Keep it short and to the point. 0.79. What is the ratio of the Imports (in Local Currency Unit) in Congo (Democratic) in 1997 to that in 1998?
Offer a terse response. 0.37. What is the ratio of the Imports (in Local Currency Unit) of Grenada in 1997 to that in 1998?
Offer a terse response. 0.84. What is the ratio of the Imports (in Local Currency Unit) in Korea (Republic) in 1997 to that in 1998?
Make the answer very short. 1.01. What is the ratio of the Imports (in Local Currency Unit) in United Kingdom in 1997 to that in 1998?
Offer a very short reply. 0.97. What is the ratio of the Imports (in Local Currency Unit) in Congo (Democratic) in 1997 to that in 1999?
Your answer should be compact. 0.13. What is the ratio of the Imports (in Local Currency Unit) of Grenada in 1997 to that in 1999?
Make the answer very short. 0.8. What is the ratio of the Imports (in Local Currency Unit) of Korea (Republic) in 1997 to that in 1999?
Give a very brief answer. 0.95. What is the ratio of the Imports (in Local Currency Unit) in United Kingdom in 1997 to that in 1999?
Ensure brevity in your answer.  0.91. What is the ratio of the Imports (in Local Currency Unit) in Congo (Democratic) in 1997 to that in 2000?
Offer a very short reply. 0.01. What is the ratio of the Imports (in Local Currency Unit) of Grenada in 1997 to that in 2000?
Keep it short and to the point. 0.69. What is the ratio of the Imports (in Local Currency Unit) in Korea (Republic) in 1997 to that in 2000?
Give a very brief answer. 0.77. What is the ratio of the Imports (in Local Currency Unit) in United Kingdom in 1997 to that in 2000?
Offer a very short reply. 0.81. What is the ratio of the Imports (in Local Currency Unit) of Congo (Democratic) in 1998 to that in 1999?
Offer a terse response. 0.36. What is the ratio of the Imports (in Local Currency Unit) in Grenada in 1998 to that in 1999?
Provide a short and direct response. 0.95. What is the ratio of the Imports (in Local Currency Unit) in Korea (Republic) in 1998 to that in 1999?
Provide a short and direct response. 0.94. What is the ratio of the Imports (in Local Currency Unit) in United Kingdom in 1998 to that in 1999?
Provide a short and direct response. 0.94. What is the ratio of the Imports (in Local Currency Unit) of Congo (Democratic) in 1998 to that in 2000?
Offer a very short reply. 0.02. What is the ratio of the Imports (in Local Currency Unit) in Grenada in 1998 to that in 2000?
Ensure brevity in your answer.  0.82. What is the ratio of the Imports (in Local Currency Unit) in Korea (Republic) in 1998 to that in 2000?
Offer a very short reply. 0.77. What is the ratio of the Imports (in Local Currency Unit) in United Kingdom in 1998 to that in 2000?
Give a very brief answer. 0.83. What is the ratio of the Imports (in Local Currency Unit) in Congo (Democratic) in 1999 to that in 2000?
Offer a very short reply. 0.04. What is the ratio of the Imports (in Local Currency Unit) of Grenada in 1999 to that in 2000?
Provide a short and direct response. 0.86. What is the ratio of the Imports (in Local Currency Unit) in Korea (Republic) in 1999 to that in 2000?
Provide a succinct answer. 0.82. What is the ratio of the Imports (in Local Currency Unit) of United Kingdom in 1999 to that in 2000?
Your answer should be very brief. 0.89. What is the difference between the highest and the second highest Imports (in Local Currency Unit) of Congo (Democratic)?
Your response must be concise. 1.96e+11. What is the difference between the highest and the second highest Imports (in Local Currency Unit) in Grenada?
Offer a terse response. 1.18e+08. What is the difference between the highest and the second highest Imports (in Local Currency Unit) in Korea (Republic)?
Your response must be concise. 3.78e+13. What is the difference between the highest and the second highest Imports (in Local Currency Unit) of United Kingdom?
Provide a short and direct response. 3.17e+1. What is the difference between the highest and the lowest Imports (in Local Currency Unit) in Congo (Democratic)?
Make the answer very short. 2.05e+11. What is the difference between the highest and the lowest Imports (in Local Currency Unit) of Grenada?
Make the answer very short. 4.25e+08. What is the difference between the highest and the lowest Imports (in Local Currency Unit) in Korea (Republic)?
Keep it short and to the point. 8.99e+13. What is the difference between the highest and the lowest Imports (in Local Currency Unit) of United Kingdom?
Your response must be concise. 7.99e+1. 